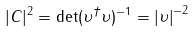<formula> <loc_0><loc_0><loc_500><loc_500>| C | ^ { 2 } = \det ( \upsilon ^ { \dagger } \upsilon ) ^ { - 1 } = \left | \upsilon \right | ^ { - 2 }</formula> 